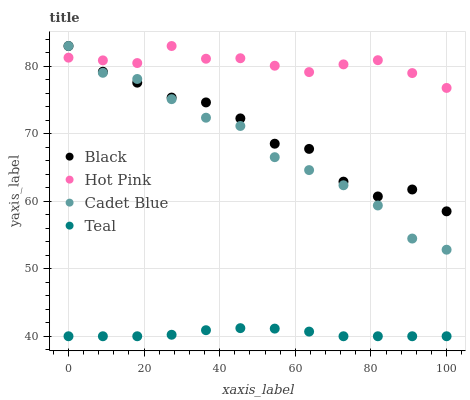Does Teal have the minimum area under the curve?
Answer yes or no. Yes. Does Hot Pink have the maximum area under the curve?
Answer yes or no. Yes. Does Black have the minimum area under the curve?
Answer yes or no. No. Does Black have the maximum area under the curve?
Answer yes or no. No. Is Teal the smoothest?
Answer yes or no. Yes. Is Black the roughest?
Answer yes or no. Yes. Is Hot Pink the smoothest?
Answer yes or no. No. Is Hot Pink the roughest?
Answer yes or no. No. Does Teal have the lowest value?
Answer yes or no. Yes. Does Black have the lowest value?
Answer yes or no. No. Does Black have the highest value?
Answer yes or no. Yes. Does Teal have the highest value?
Answer yes or no. No. Is Teal less than Black?
Answer yes or no. Yes. Is Black greater than Teal?
Answer yes or no. Yes. Does Cadet Blue intersect Black?
Answer yes or no. Yes. Is Cadet Blue less than Black?
Answer yes or no. No. Is Cadet Blue greater than Black?
Answer yes or no. No. Does Teal intersect Black?
Answer yes or no. No. 